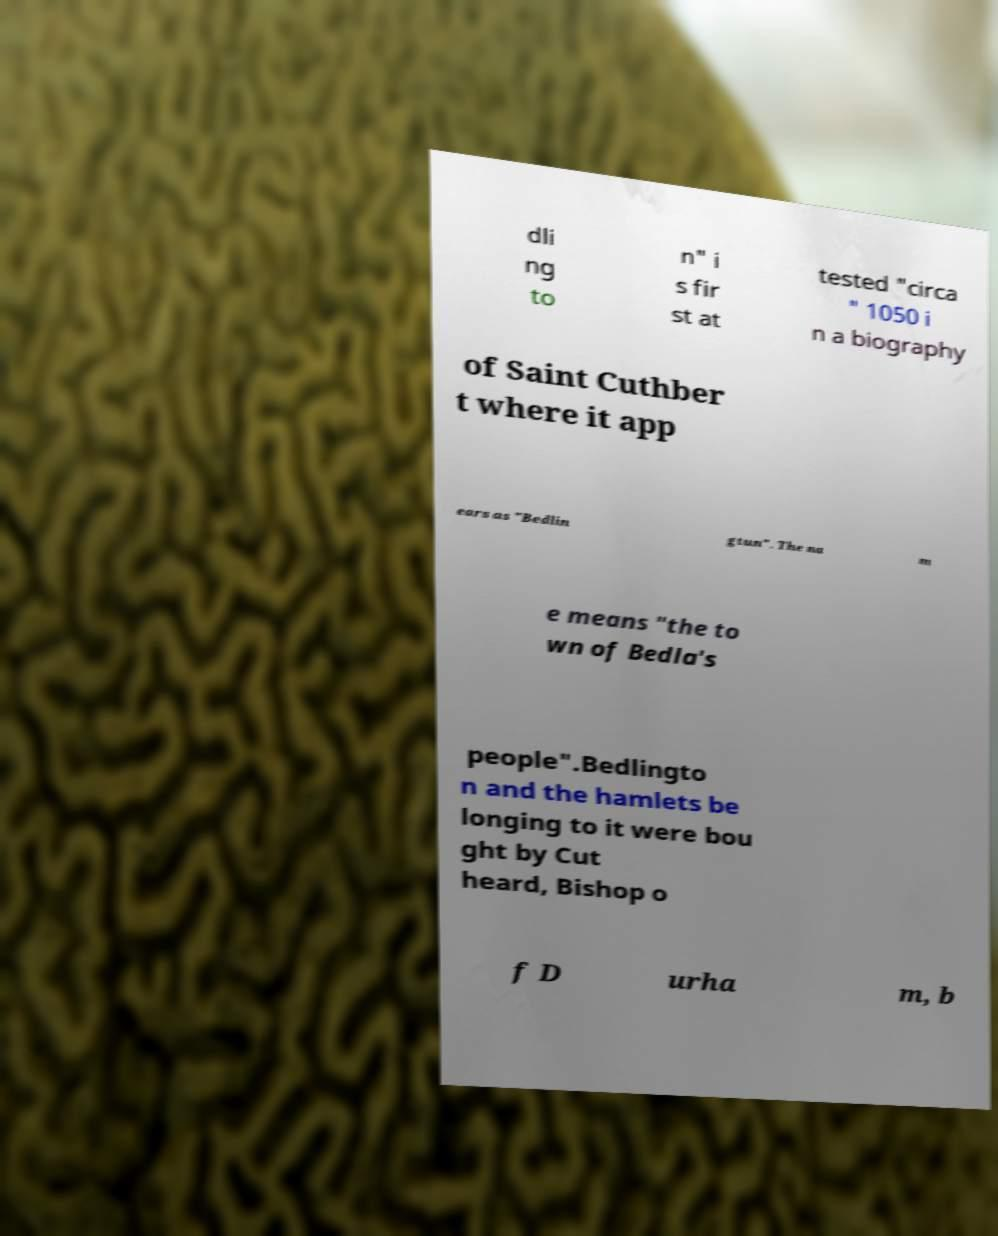Could you assist in decoding the text presented in this image and type it out clearly? dli ng to n" i s fir st at tested "circa " 1050 i n a biography of Saint Cuthber t where it app ears as "Bedlin gtun". The na m e means "the to wn of Bedla's people".Bedlingto n and the hamlets be longing to it were bou ght by Cut heard, Bishop o f D urha m, b 